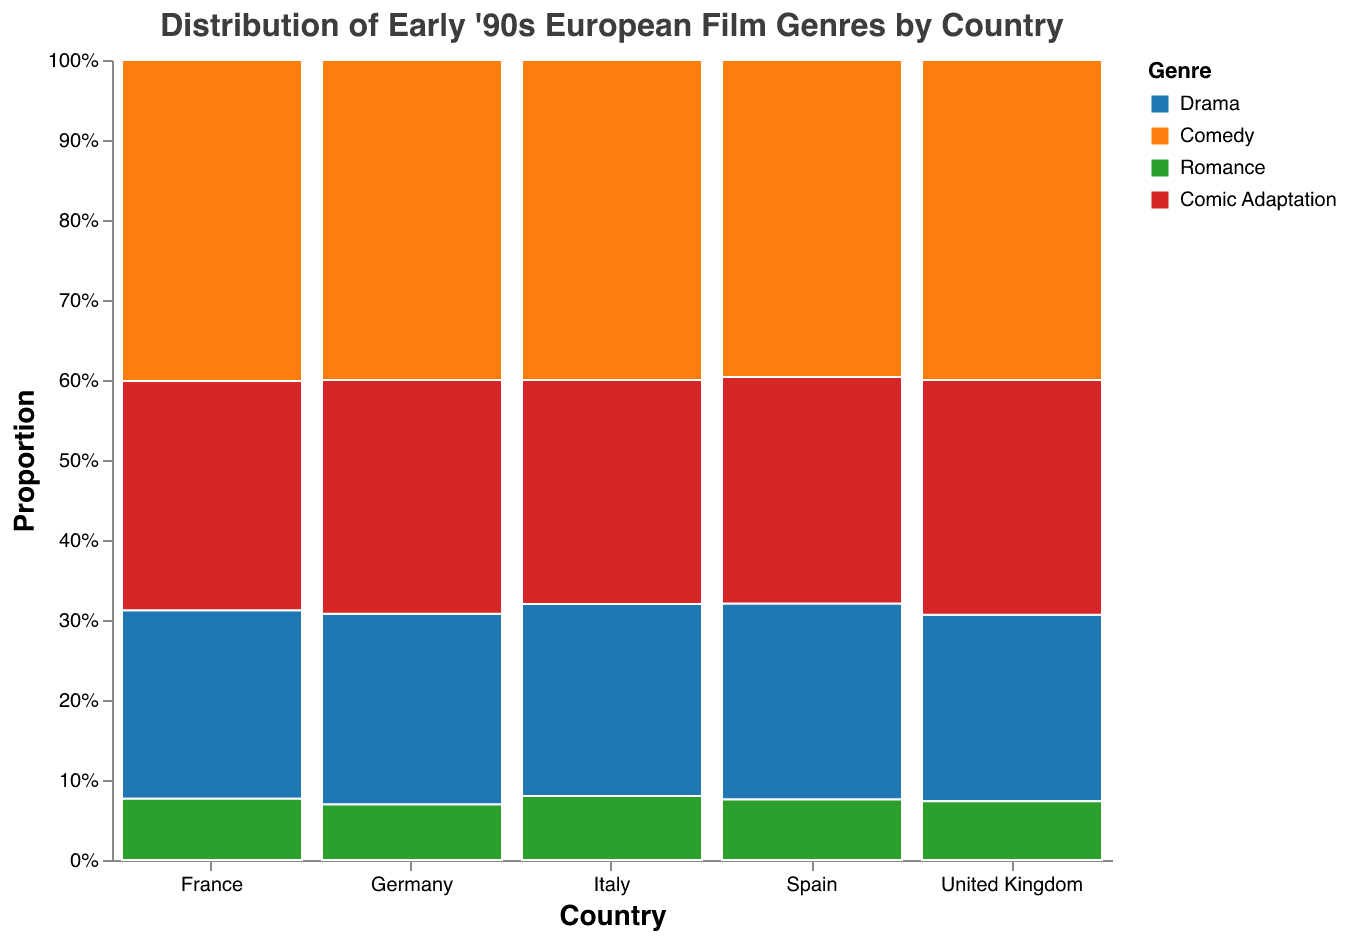Which country has the highest proportion of Drama films? The proportion for each genre in each country is indicated by the height of the corresponding segment in the mosaic plot. The United Kingdom has a larger Drama segment compared to other countries.
Answer: United Kingdom Which genre is the least represented in Spanish films? By comparing the segment sizes within Spain, Comic Adaptation has the smallest segment, making it the least represented genre.
Answer: Comic Adaptation What is the total count of Comedy films across all countries? Sum the counts of Comedy films from each country: 18 (France) + 15 (Italy) + 14 (Germany) + 12 (Spain) + 16 (United Kingdom) = 75
Answer: 75 How does the proportion of Romance films in France compare to that in Germany? Compare the height of the Romance segment of France with that of Germany. In France, the Romance segment is higher than in Germany, indicating a higher proportion.
Answer: Higher in France Are Comic Adaptation films more popular in the United Kingdom or Italy? Compare the height of the Comic Adaptation segments in the United Kingdom to those in Italy. The segment in the United Kingdom is taller, implying a higher proportion.
Answer: United Kingdom How does the distribution of film genres in Italy compare to Spain? Compare the relative segment heights for each genre between Italy and Spain. Notice the differences in proportions for Drama, Comedy, Romance, and Comic Adaptation films.
Answer: Italy has more Drama and Comedy films, while proportions for other genres are similar In which country is the overall highest diversity in film genres observed? Diversity can be measured by the similarity in the proportion of different genres. The United Kingdom shows more balanced proportions across all genres.
Answer: United Kingdom What is the primary genre of films in Germany? The primary genre would be the one with the largest segment. In Germany, Drama has the largest segment.
Answer: Drama 